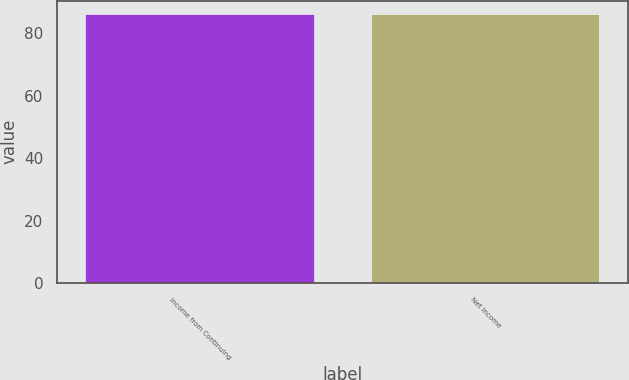Convert chart to OTSL. <chart><loc_0><loc_0><loc_500><loc_500><bar_chart><fcel>Income from Continuing<fcel>Net Income<nl><fcel>86<fcel>86.1<nl></chart> 